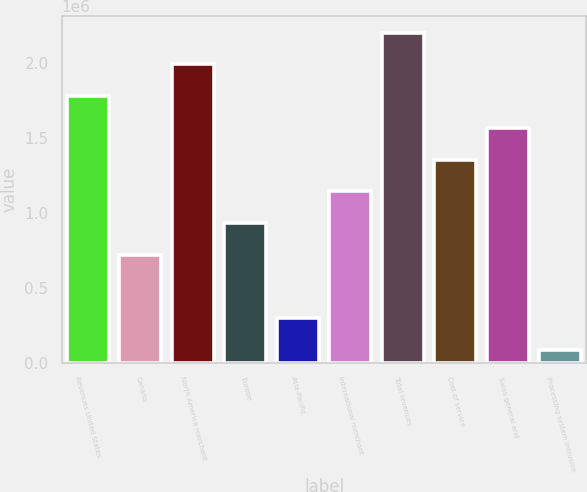Convert chart to OTSL. <chart><loc_0><loc_0><loc_500><loc_500><bar_chart><fcel>Revenues United States<fcel>Canada<fcel>North America merchant<fcel>Europe<fcel>Asia-Pacific<fcel>International merchant<fcel>Total revenues<fcel>Cost of service<fcel>Sales general and<fcel>Processing system intrusion<nl><fcel>1.77997e+06<fcel>720261<fcel>1.99191e+06<fcel>932202<fcel>296379<fcel>1.14414e+06<fcel>2.20385e+06<fcel>1.35608e+06<fcel>1.56802e+06<fcel>84438<nl></chart> 